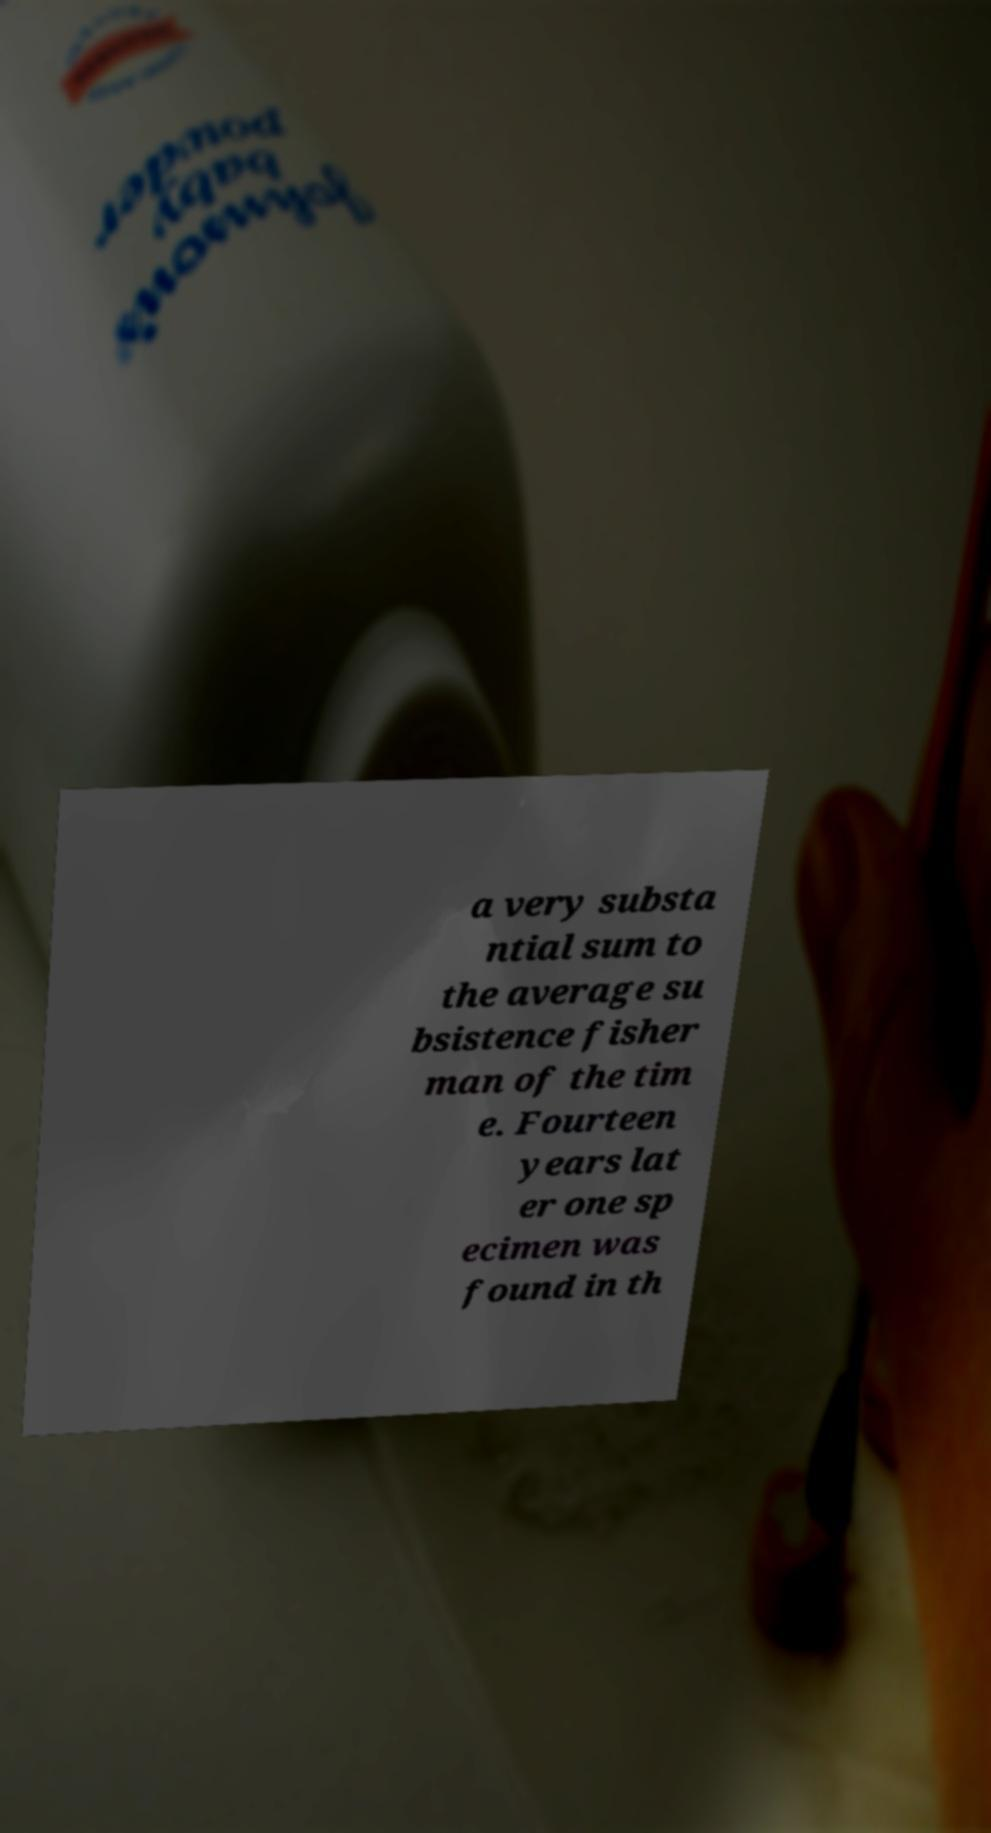Please read and relay the text visible in this image. What does it say? a very substa ntial sum to the average su bsistence fisher man of the tim e. Fourteen years lat er one sp ecimen was found in th 